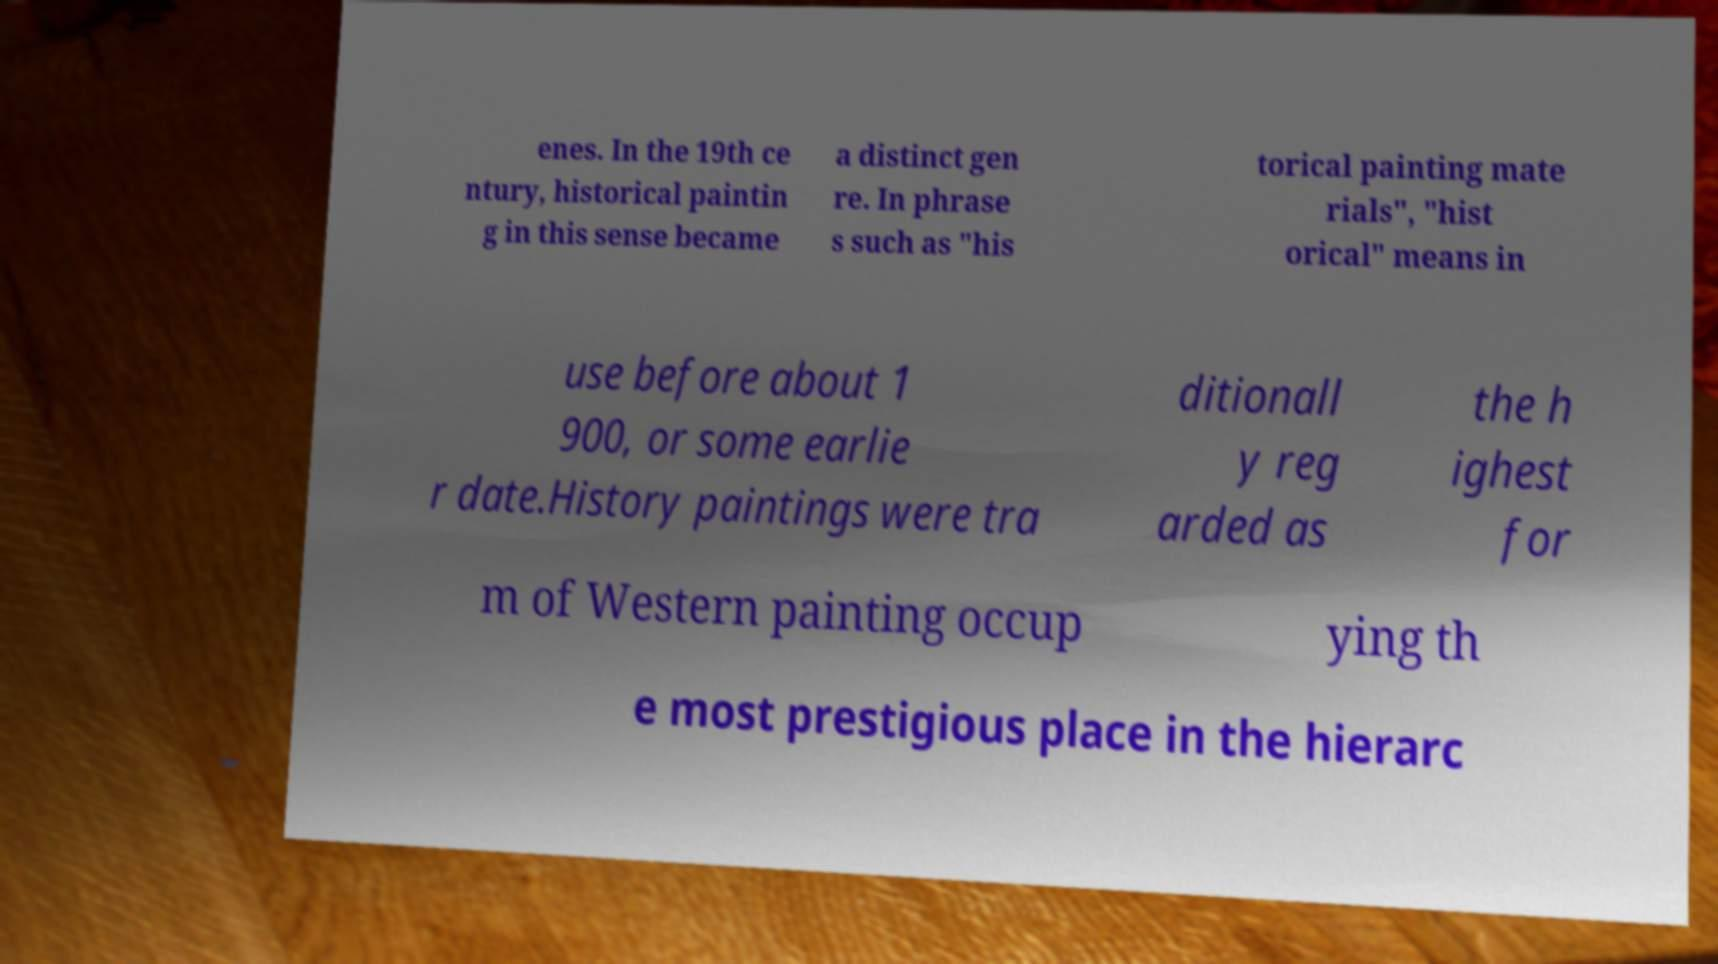Can you accurately transcribe the text from the provided image for me? enes. In the 19th ce ntury, historical paintin g in this sense became a distinct gen re. In phrase s such as "his torical painting mate rials", "hist orical" means in use before about 1 900, or some earlie r date.History paintings were tra ditionall y reg arded as the h ighest for m of Western painting occup ying th e most prestigious place in the hierarc 